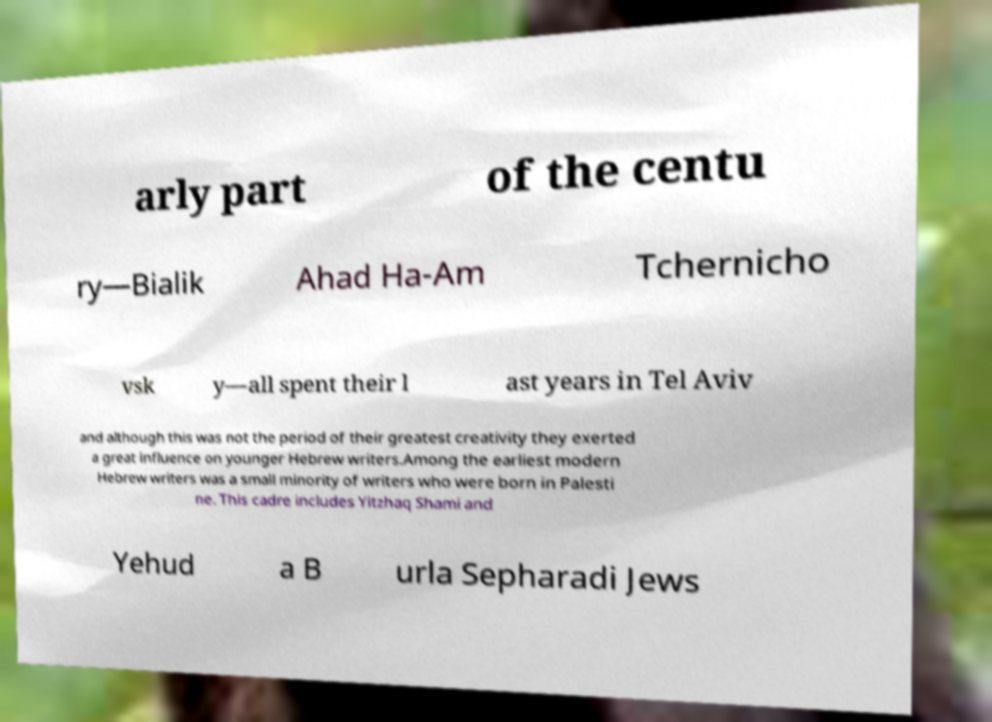For documentation purposes, I need the text within this image transcribed. Could you provide that? arly part of the centu ry—Bialik Ahad Ha-Am Tchernicho vsk y—all spent their l ast years in Tel Aviv and although this was not the period of their greatest creativity they exerted a great influence on younger Hebrew writers.Among the earliest modern Hebrew writers was a small minority of writers who were born in Palesti ne. This cadre includes Yitzhaq Shami and Yehud a B urla Sepharadi Jews 